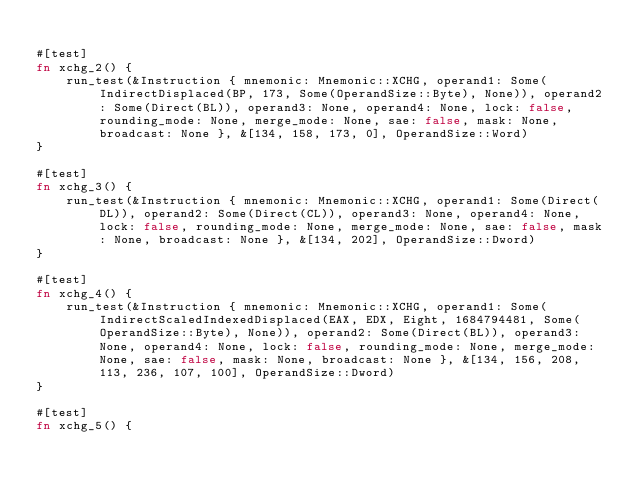Convert code to text. <code><loc_0><loc_0><loc_500><loc_500><_Rust_>
#[test]
fn xchg_2() {
    run_test(&Instruction { mnemonic: Mnemonic::XCHG, operand1: Some(IndirectDisplaced(BP, 173, Some(OperandSize::Byte), None)), operand2: Some(Direct(BL)), operand3: None, operand4: None, lock: false, rounding_mode: None, merge_mode: None, sae: false, mask: None, broadcast: None }, &[134, 158, 173, 0], OperandSize::Word)
}

#[test]
fn xchg_3() {
    run_test(&Instruction { mnemonic: Mnemonic::XCHG, operand1: Some(Direct(DL)), operand2: Some(Direct(CL)), operand3: None, operand4: None, lock: false, rounding_mode: None, merge_mode: None, sae: false, mask: None, broadcast: None }, &[134, 202], OperandSize::Dword)
}

#[test]
fn xchg_4() {
    run_test(&Instruction { mnemonic: Mnemonic::XCHG, operand1: Some(IndirectScaledIndexedDisplaced(EAX, EDX, Eight, 1684794481, Some(OperandSize::Byte), None)), operand2: Some(Direct(BL)), operand3: None, operand4: None, lock: false, rounding_mode: None, merge_mode: None, sae: false, mask: None, broadcast: None }, &[134, 156, 208, 113, 236, 107, 100], OperandSize::Dword)
}

#[test]
fn xchg_5() {</code> 